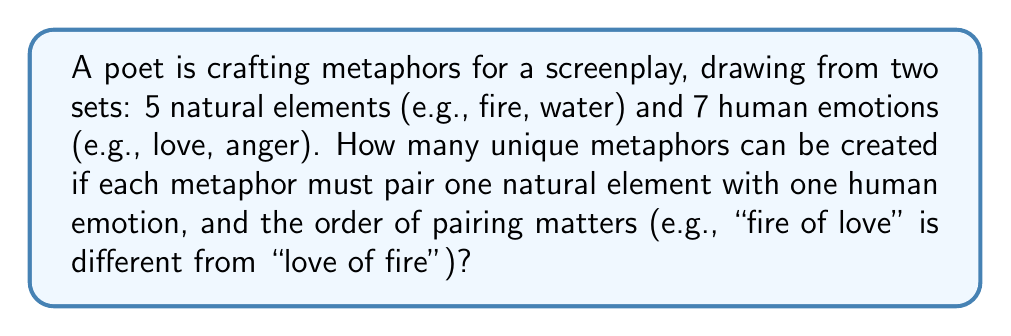Give your solution to this math problem. Let's approach this step-by-step:

1) We are essentially creating ordered pairs from two sets:
   - Set A: 5 natural elements
   - Set B: 7 human emotions

2) For each metaphor, we need to choose:
   - One element from Set A
   - One emotion from Set B

3) The order matters, meaning "fire of love" is considered different from "love of fire".

4) This scenario fits the multiplication principle of counting.

5) We can choose any of the 5 elements for the first part of our metaphor.

6) For each of these choices, we can then choose any of the 7 emotions for the second part.

7) Therefore, the total number of unique metaphors is:

   $$ 5 \times 7 = 35 $$

8) We can also think of this as a permutation with repetition allowed:
   $$ P(n,r) = n^r $$
   Where $n$ is the total number of options (5 + 7 = 12) and $r$ is the number of selections (2).

   $$ P(12,2) = 12^2 = 144 $$

   However, this would include invalid combinations like "fire of fire" or "love of love", which we need to subtract:

   $$ 12^2 - 5^2 - 7^2 = 144 - 25 - 49 = 70 $$

9) The result 70 represents the total number of metaphors if we consider both orders ("fire of love" and "love of fire" as separate metaphors).

10) Since the question asks for the number of unique pairings, we divide this by 2:

    $$ 70 \div 2 = 35 $$

Thus, we arrive at the same answer of 35 unique metaphors.
Answer: 35 